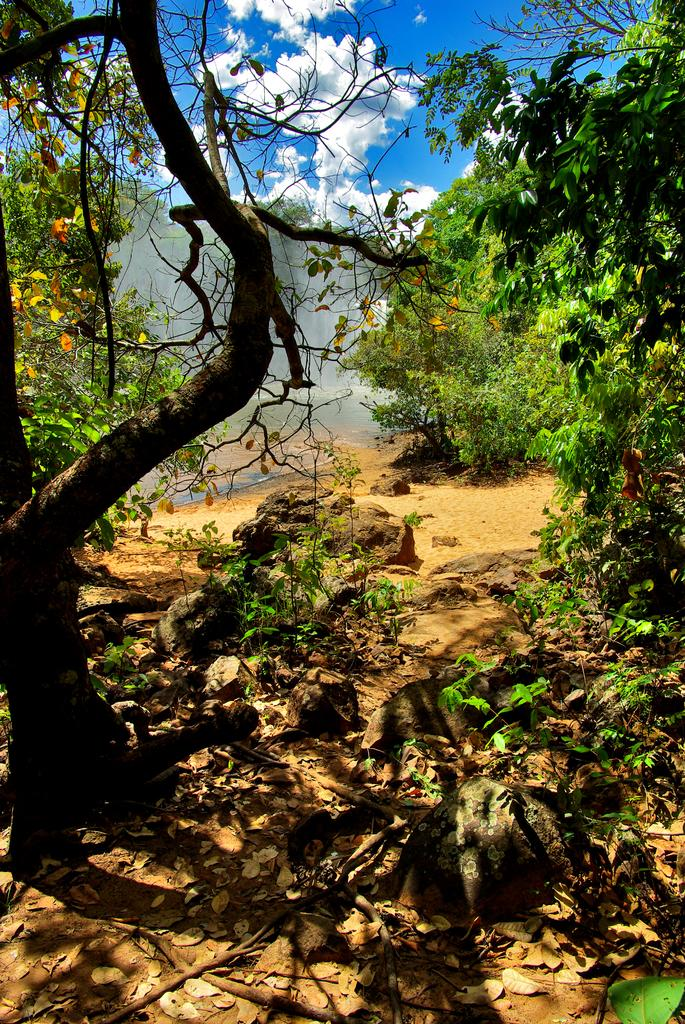What type of setting is depicted in the image? The image is an outside view. What can be seen on the ground in the image? There are many plants and trees on the ground. What is visible at the top of the image? The sky is visible at the top of the image. What can be observed in the sky in the image? Clouds are present in the sky. Where is the girl sitting with the lamp in the image? There is no girl or lamp present in the image; it is an outside view with plants, trees, and clouds in the sky. 